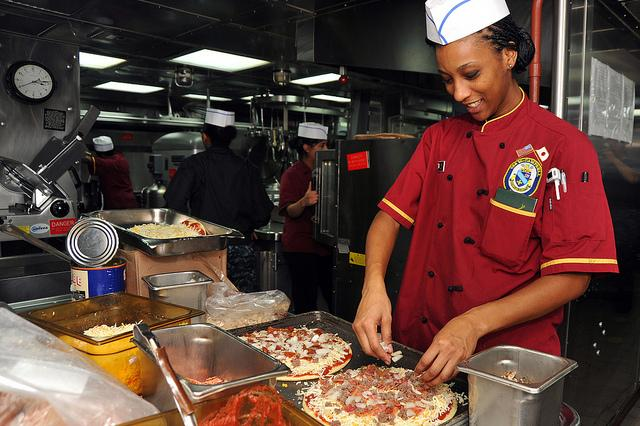What period of the day is it in the image?

Choices:
A) night
B) morning
C) evening
D) afternoon afternoon 